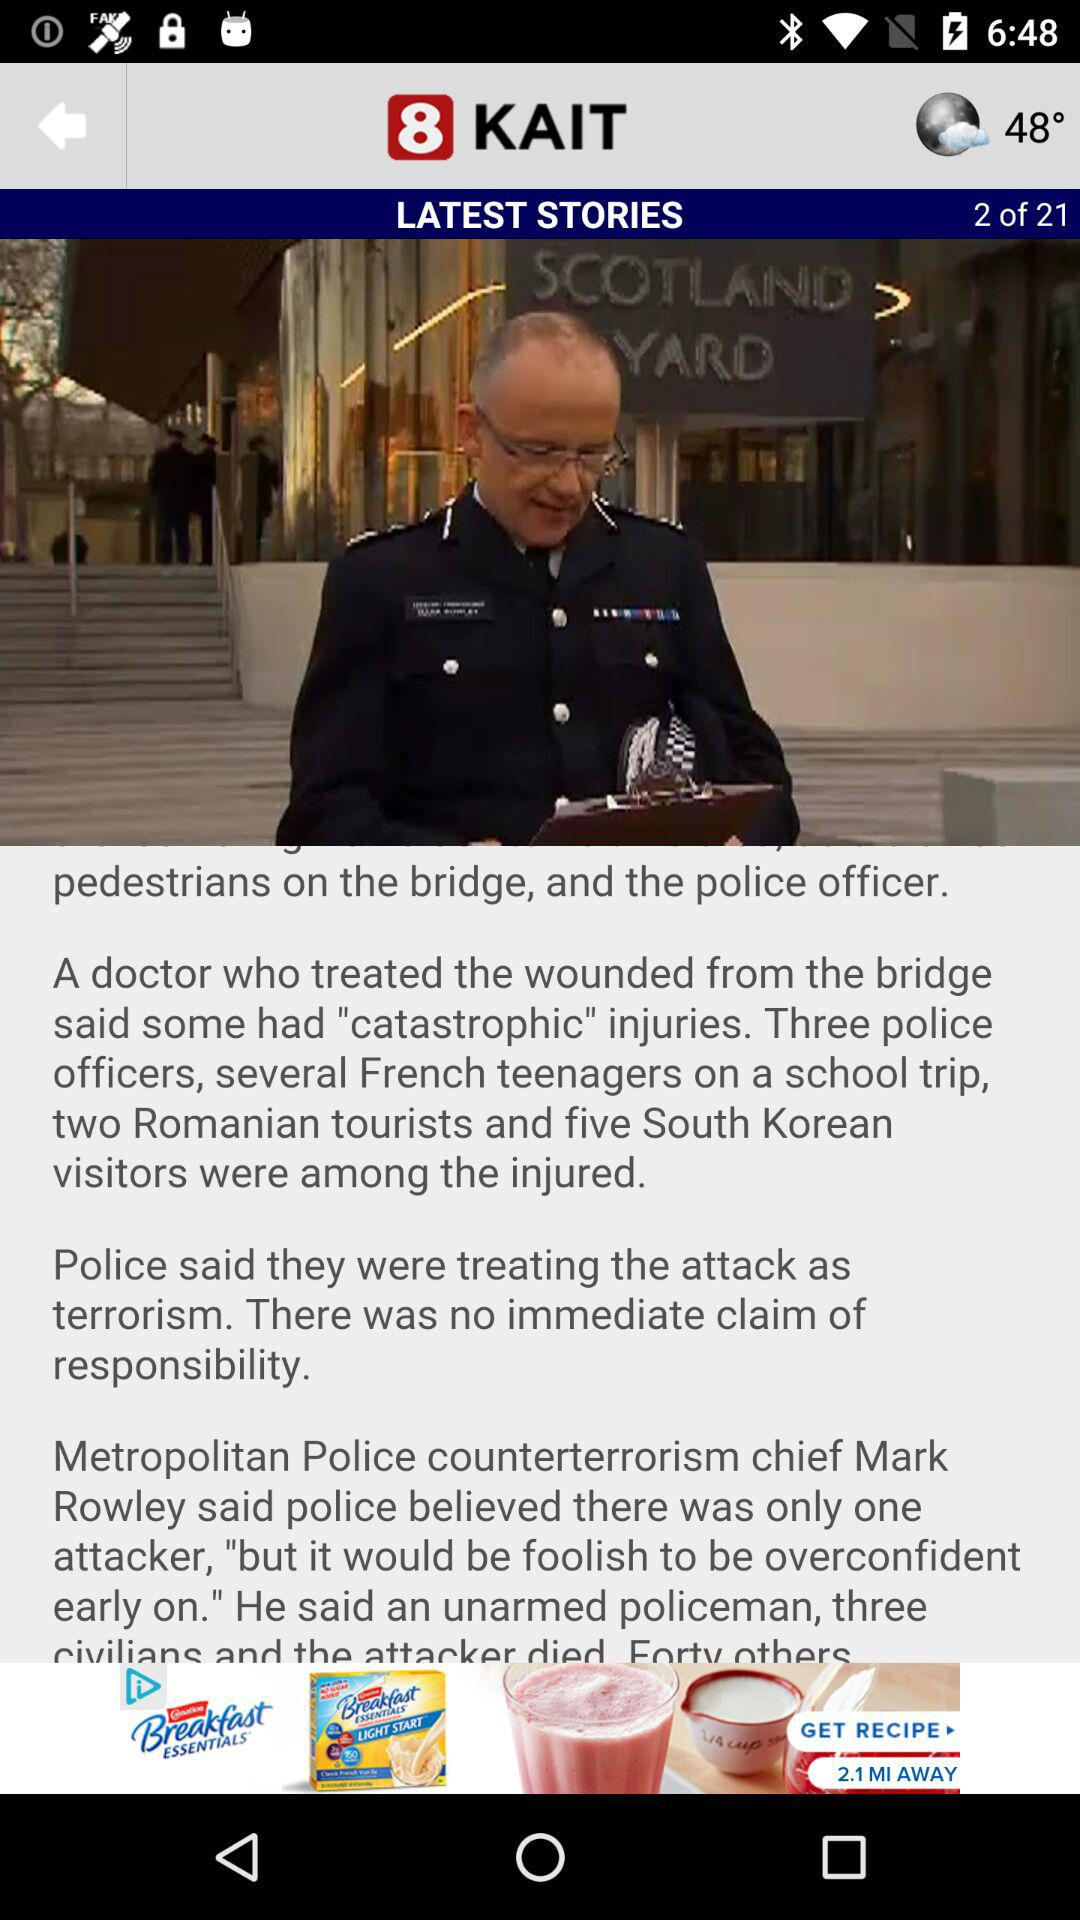What is the name of the application? The name of the application is "KAIT". 